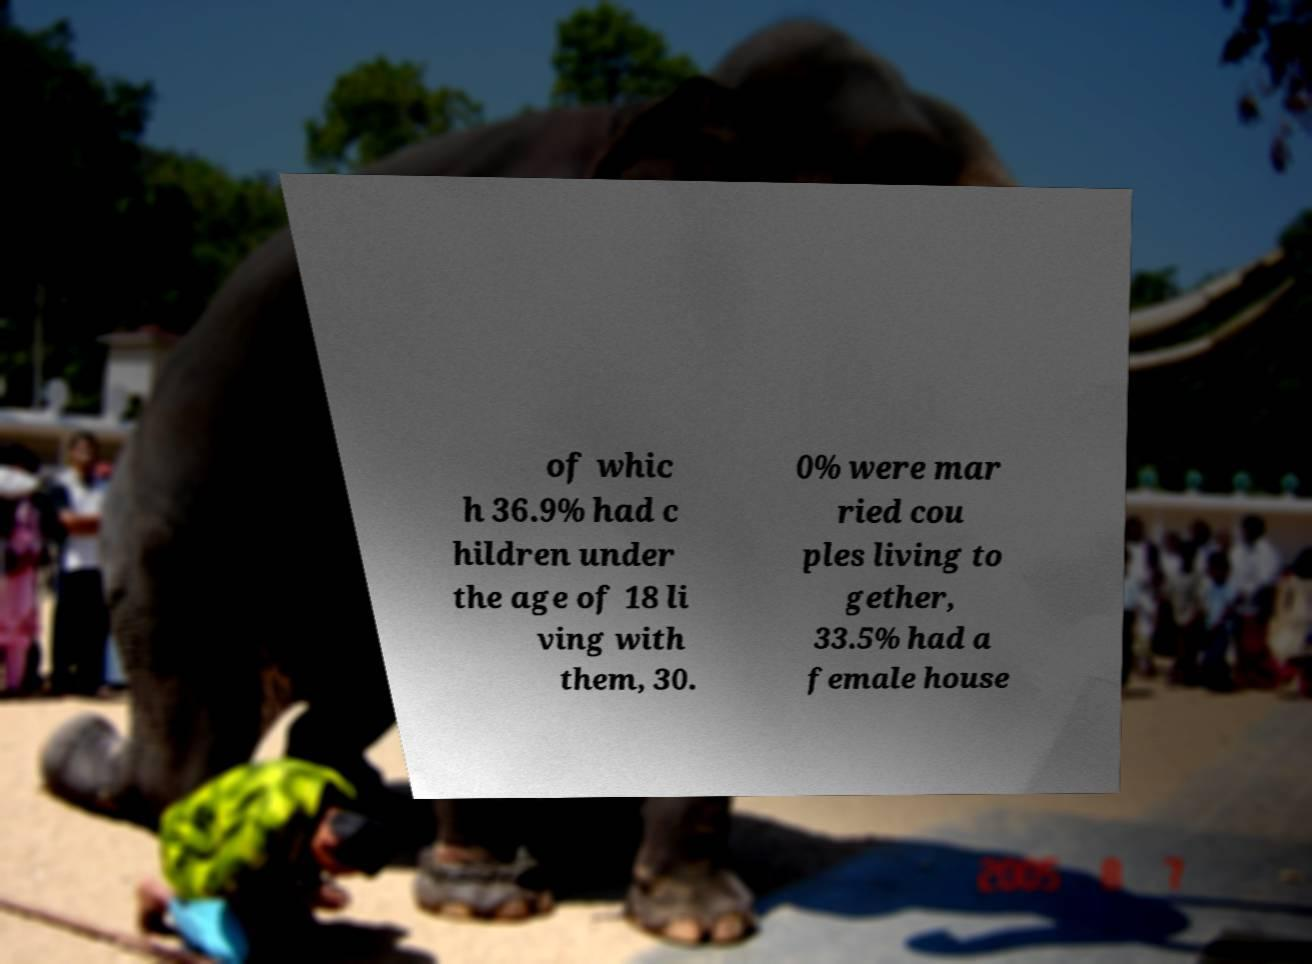Could you assist in decoding the text presented in this image and type it out clearly? of whic h 36.9% had c hildren under the age of 18 li ving with them, 30. 0% were mar ried cou ples living to gether, 33.5% had a female house 